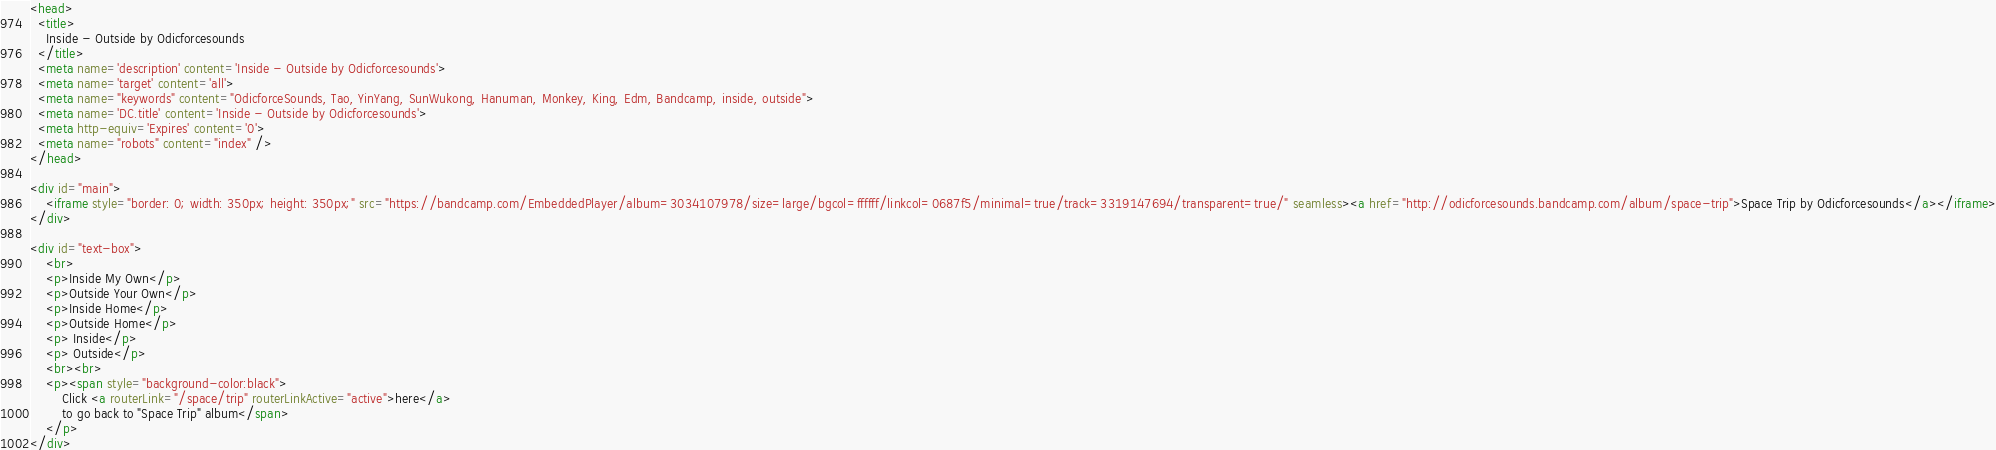<code> <loc_0><loc_0><loc_500><loc_500><_HTML_><head>
  <title>
    Inside - Outside by Odicforcesounds
  </title>
  <meta name='description' content='Inside - Outside by Odicforcesounds'>
  <meta name='target' content='all'>
  <meta name="keywords" content="OdicforceSounds, Tao, YinYang, SunWukong, Hanuman, Monkey, King, Edm, Bandcamp, inside, outside">
  <meta name='DC.title' content='Inside - Outside by Odicforcesounds'>
  <meta http-equiv='Expires' content='0'>
  <meta name="robots" content="index" />
</head>

<div id="main">
    <iframe style="border: 0; width: 350px; height: 350px;" src="https://bandcamp.com/EmbeddedPlayer/album=3034107978/size=large/bgcol=ffffff/linkcol=0687f5/minimal=true/track=3319147694/transparent=true/" seamless><a href="http://odicforcesounds.bandcamp.com/album/space-trip">Space Trip by Odicforcesounds</a></iframe>
</div>

<div id="text-box">
    <br>
    <p>Inside My Own</p>
    <p>Outside Your Own</p>
    <p>Inside Home</p>
    <p>Outside Home</p>
    <p> Inside</p>
    <p> Outside</p>
    <br><br>
    <p><span style="background-color:black">
        Click <a routerLink="/space/trip" routerLinkActive="active">here</a>
        to go back to "Space Trip" album</span>
    </p>
</div>
</code> 